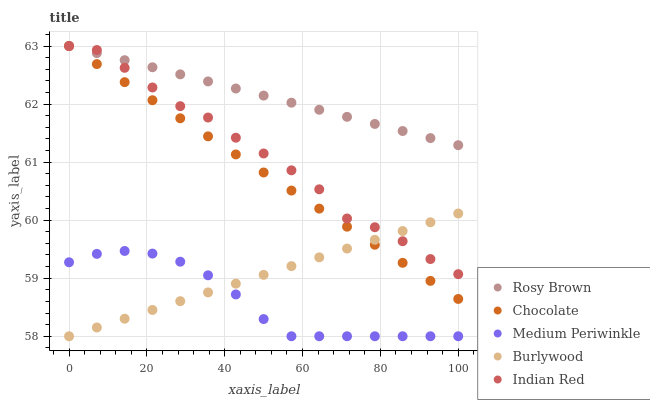Does Medium Periwinkle have the minimum area under the curve?
Answer yes or no. Yes. Does Rosy Brown have the maximum area under the curve?
Answer yes or no. Yes. Does Rosy Brown have the minimum area under the curve?
Answer yes or no. No. Does Medium Periwinkle have the maximum area under the curve?
Answer yes or no. No. Is Rosy Brown the smoothest?
Answer yes or no. Yes. Is Indian Red the roughest?
Answer yes or no. Yes. Is Medium Periwinkle the smoothest?
Answer yes or no. No. Is Medium Periwinkle the roughest?
Answer yes or no. No. Does Burlywood have the lowest value?
Answer yes or no. Yes. Does Rosy Brown have the lowest value?
Answer yes or no. No. Does Chocolate have the highest value?
Answer yes or no. Yes. Does Medium Periwinkle have the highest value?
Answer yes or no. No. Is Medium Periwinkle less than Chocolate?
Answer yes or no. Yes. Is Rosy Brown greater than Medium Periwinkle?
Answer yes or no. Yes. Does Medium Periwinkle intersect Burlywood?
Answer yes or no. Yes. Is Medium Periwinkle less than Burlywood?
Answer yes or no. No. Is Medium Periwinkle greater than Burlywood?
Answer yes or no. No. Does Medium Periwinkle intersect Chocolate?
Answer yes or no. No. 